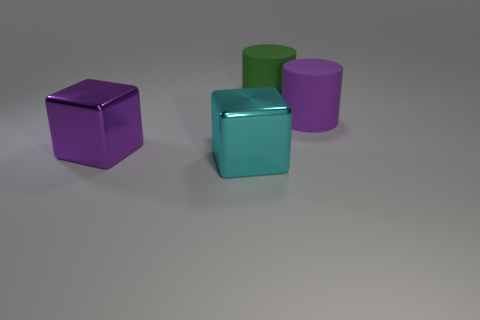Can you describe the shapes and colors of the objects in the image? Certainly! The image showcases three geometric objects placed on a flat surface. From left to right, there is a cube with a purple matte finish, a slightly larger cube with a glossy cyan surface, and a matte cylinder with a soft purple hue. The background is neutral, creating a contrast that highlights the objects. 